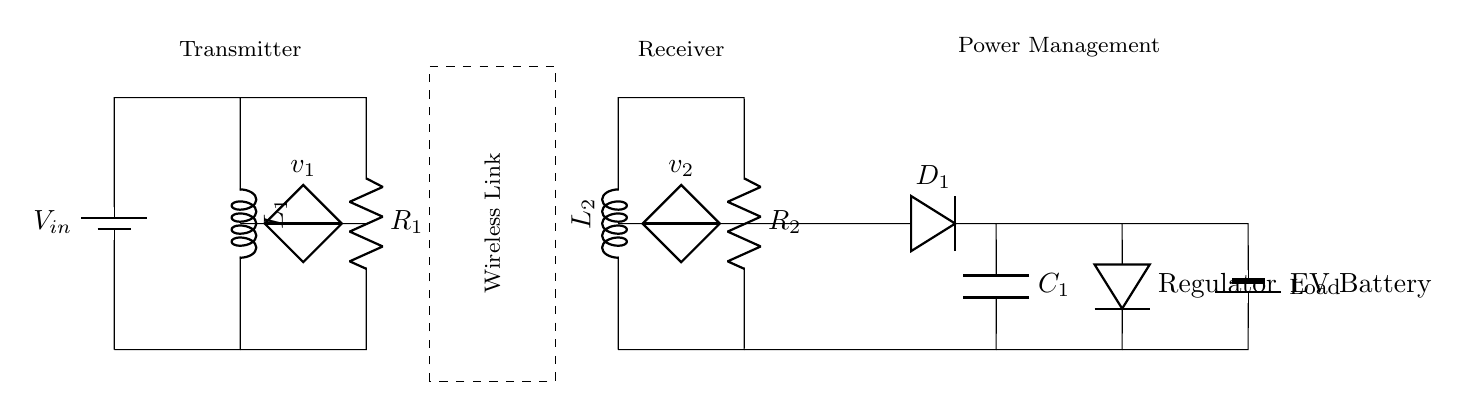What is the voltage input in this circuit? The input voltage is represented as V subscript in, which is shown at the top left of the circuit.
Answer: V in What components are present in the transmitter part of the circuit? The transmitter consists of a battery, an inductor labeled L1, and a resistor labeled R1. These components are connected to allow current flow and energy transfer.
Answer: Battery, L1, R1 What is the role of the wireless link indicated in the diagram? The wireless link's role is to transfer energy inductively between the transmitter and receiver without physical connections, allowing for a high-efficiency wireless charging system.
Answer: Energy transfer How many inductors are in the circuit? There are two inductors present in this circuit, identified as L1 and L2, located in the transmitter and receiver sections, respectively.
Answer: 2 What is the function of the rectifier in the receiver circuit? The rectifier, indicated by the diode labeled D1, converts alternating current from the wireless transfer into direct current for charging the electric vehicle's battery.
Answer: Conversion How does the energy management system operate in this circuit? The energy management system comprises a regulator after the rectifier, ensuring a stable output voltage to charge the EV battery, preventing overcharging and optimizing performance.
Answer: Stabilizes voltage 